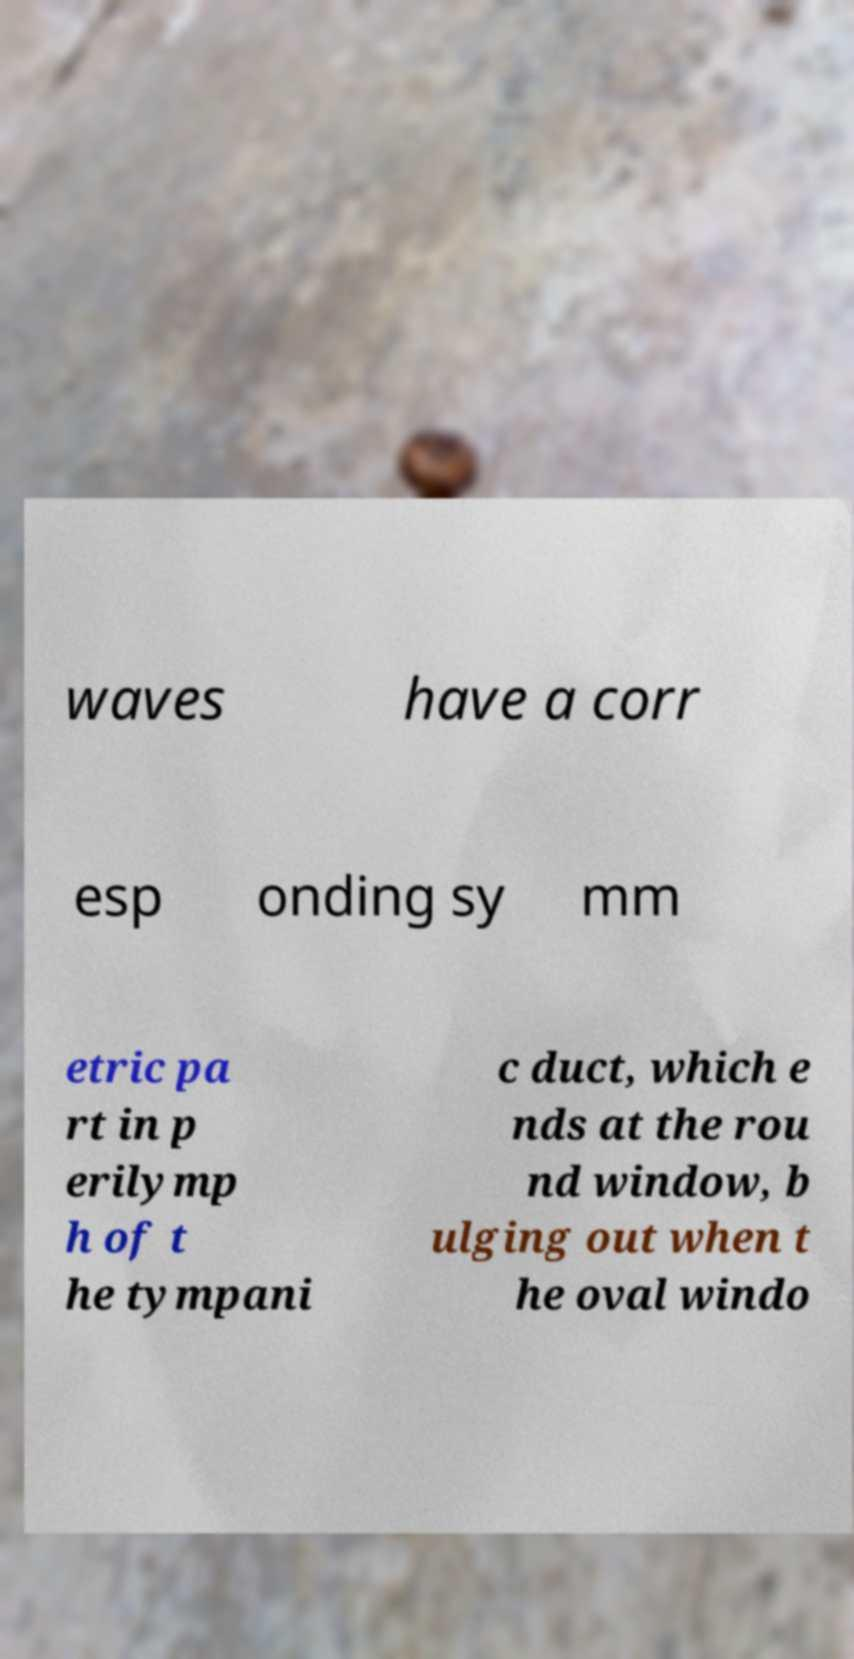For documentation purposes, I need the text within this image transcribed. Could you provide that? waves have a corr esp onding sy mm etric pa rt in p erilymp h of t he tympani c duct, which e nds at the rou nd window, b ulging out when t he oval windo 